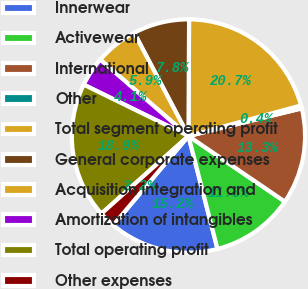Convert chart to OTSL. <chart><loc_0><loc_0><loc_500><loc_500><pie_chart><fcel>Innerwear<fcel>Activewear<fcel>International<fcel>Other<fcel>Total segment operating profit<fcel>General corporate expenses<fcel>Acquisition integration and<fcel>Amortization of intangibles<fcel>Total operating profit<fcel>Other expenses<nl><fcel>15.16%<fcel>11.48%<fcel>13.32%<fcel>0.41%<fcel>20.7%<fcel>7.79%<fcel>5.94%<fcel>4.1%<fcel>18.85%<fcel>2.25%<nl></chart> 